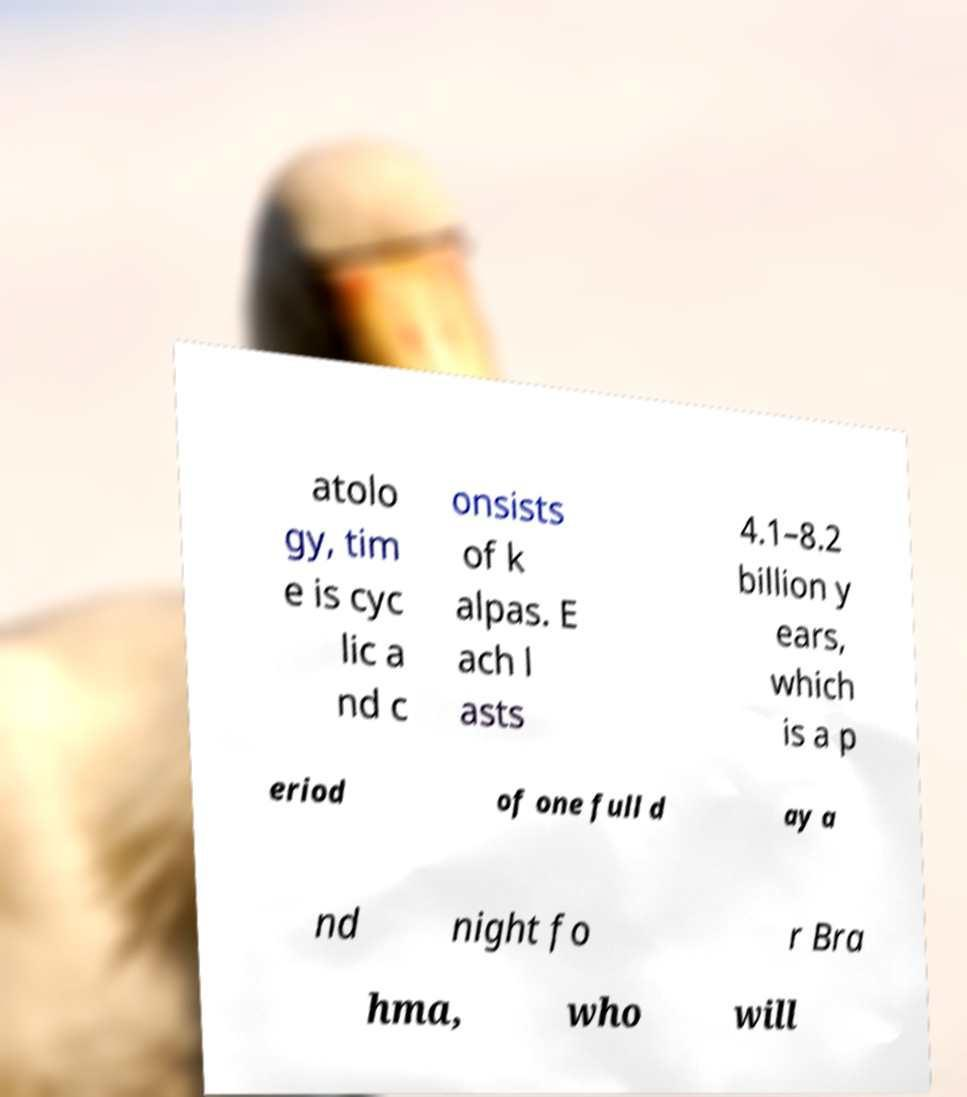Can you read and provide the text displayed in the image?This photo seems to have some interesting text. Can you extract and type it out for me? atolo gy, tim e is cyc lic a nd c onsists of k alpas. E ach l asts 4.1–8.2 billion y ears, which is a p eriod of one full d ay a nd night fo r Bra hma, who will 